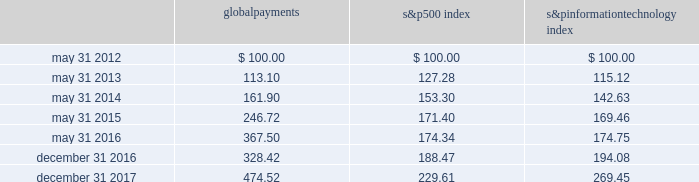Stock performance graph the following graph compares our cumulative shareholder returns with the standard & poor 2019s information technology index and the standard & poor 2019s 500 index for the year ended december 31 , 2017 , the 2016 fiscal transition period , and the years ended may 31 , 2016 , 2015 , 2014 and 2013 .
The line graph assumes the investment of $ 100 in our common stock , the standard & poor 2019s 500 index and the standard & poor 2019s information technology index on may 31 , 2012 and assumes reinvestment of all dividends .
5/12 5/165/155/145/13 global payments inc .
S&p 500 s&p information technology 12/16 12/17 comparison of 5 year cumulative total return* among global payments inc. , the s&p 500 index and the s&p information technology index * $ 100 invested on may 31 , 2012 in stock or index , including reinvestment of dividends .
Copyright a9 2018 standard & poor 2019s , a division of s&p global .
All rights reserved .
Global payments 500 index information technology .
30 2013 global payments inc .
| 2017 form 10-k annual report .
What is the total return if 1000000 is invested in global payments in may 31 , 2012 and liquidated in may 31 , 2015? 
Computations: ((1000000 / 100) - (246.72 - 1000))
Answer: 10753.28. 